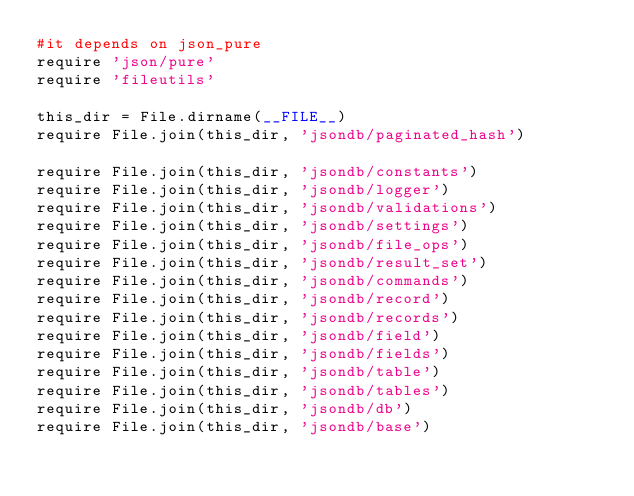<code> <loc_0><loc_0><loc_500><loc_500><_Ruby_>#it depends on json_pure
require 'json/pure'
require 'fileutils'

this_dir = File.dirname(__FILE__)
require File.join(this_dir, 'jsondb/paginated_hash')

require File.join(this_dir, 'jsondb/constants')
require File.join(this_dir, 'jsondb/logger')
require File.join(this_dir, 'jsondb/validations')
require File.join(this_dir, 'jsondb/settings')
require File.join(this_dir, 'jsondb/file_ops')
require File.join(this_dir, 'jsondb/result_set')
require File.join(this_dir, 'jsondb/commands')
require File.join(this_dir, 'jsondb/record')
require File.join(this_dir, 'jsondb/records')
require File.join(this_dir, 'jsondb/field')
require File.join(this_dir, 'jsondb/fields')
require File.join(this_dir, 'jsondb/table')
require File.join(this_dir, 'jsondb/tables')
require File.join(this_dir, 'jsondb/db')
require File.join(this_dir, 'jsondb/base')
</code> 